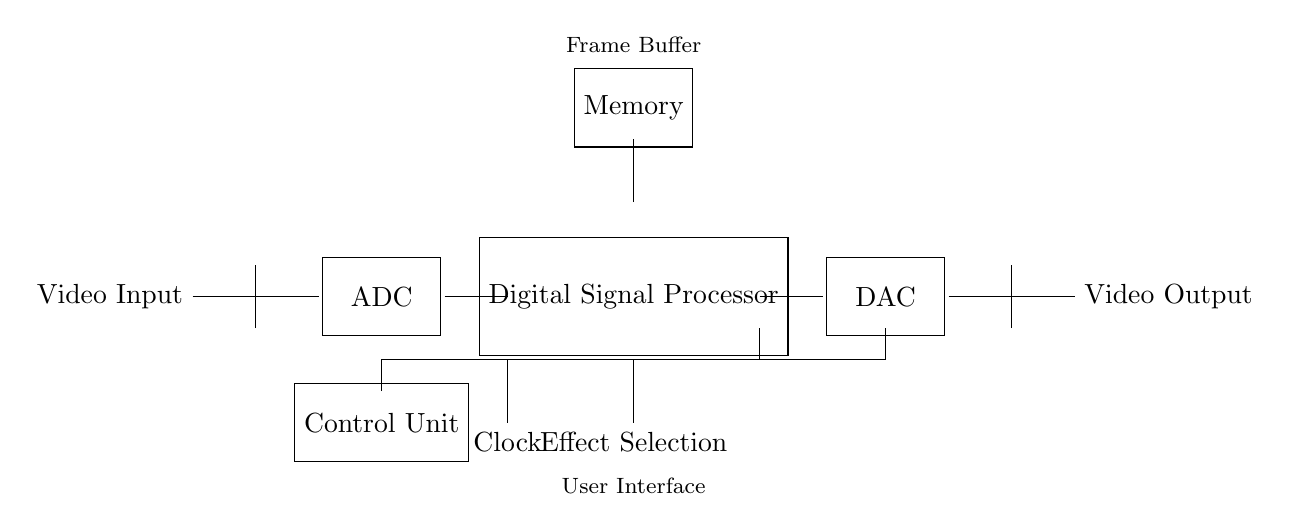What is the first component in the circuit? The first component is the Video Input, as indicated on the left side of the diagram.
Answer: Video Input What is the function of the ADC in this circuit? The ADC, or Analog-to-Digital Converter, converts the analog video signal to a digital form for processing.
Answer: Converts video signal What does the Control Unit do? The Control Unit manages the operation of the circuit, coordinating communication between the components, including the DSP, Memory, and DAC.
Answer: Manages circuit operation How many main processing stages are there in this circuit? There are three main processing stages: ADC, Digital Signal Processor, and DAC, arranged sequentially from input to output.
Answer: Three What component stores the video frames temporarily? The Memory component temporarily stores video frames for processing before they are outputted.
Answer: Memory How does the Clock influence this circuit? The Clock provides timing signals that synchronize the operations of the different components, ensuring that data is processed in a coordinated manner.
Answer: Synchronizes operations 